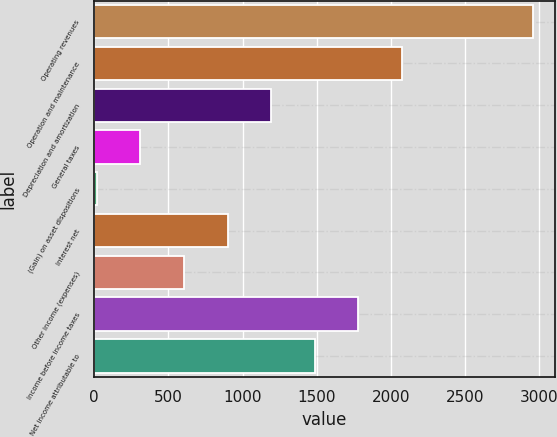Convert chart to OTSL. <chart><loc_0><loc_0><loc_500><loc_500><bar_chart><fcel>Operating revenues<fcel>Operation and maintenance<fcel>Depreciation and amortization<fcel>General taxes<fcel>(Gain) on asset dispositions<fcel>Interest net<fcel>Other income (expenses)<fcel>Income before income taxes<fcel>Net income attributable to<nl><fcel>2958<fcel>2075.4<fcel>1192.8<fcel>310.2<fcel>16<fcel>898.6<fcel>604.4<fcel>1781.2<fcel>1487<nl></chart> 